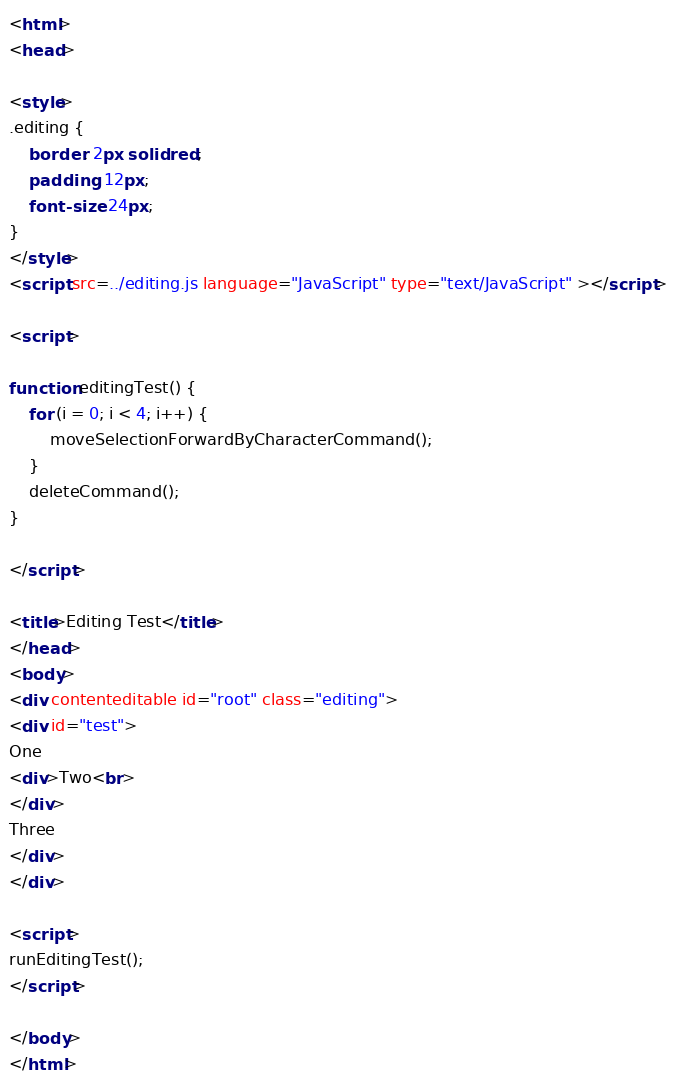<code> <loc_0><loc_0><loc_500><loc_500><_HTML_><html> 
<head>

<style>
.editing { 
    border: 2px solid red; 
    padding: 12px; 
    font-size: 24px; 
}
</style>
<script src=../editing.js language="JavaScript" type="text/JavaScript" ></script>

<script>

function editingTest() {
    for (i = 0; i < 4; i++) {
        moveSelectionForwardByCharacterCommand();    
    }
    deleteCommand();
}

</script>

<title>Editing Test</title> 
</head> 
<body>
<div contenteditable id="root" class="editing">
<div id="test">
One 
<div>Two<br>
</div>
Three
</div>
</div>

<script>
runEditingTest();
</script>

</body>
</html>
</code> 